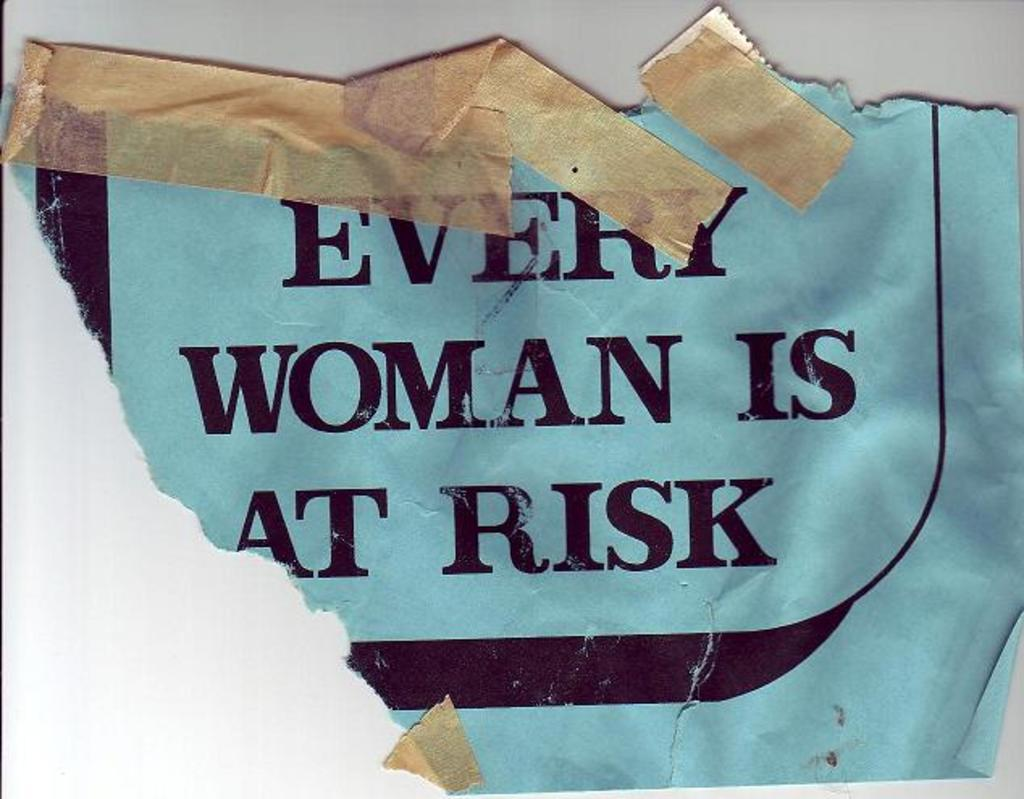<image>
Present a compact description of the photo's key features. A torn paper mounted on a wall written, 'every woman is at risk' 